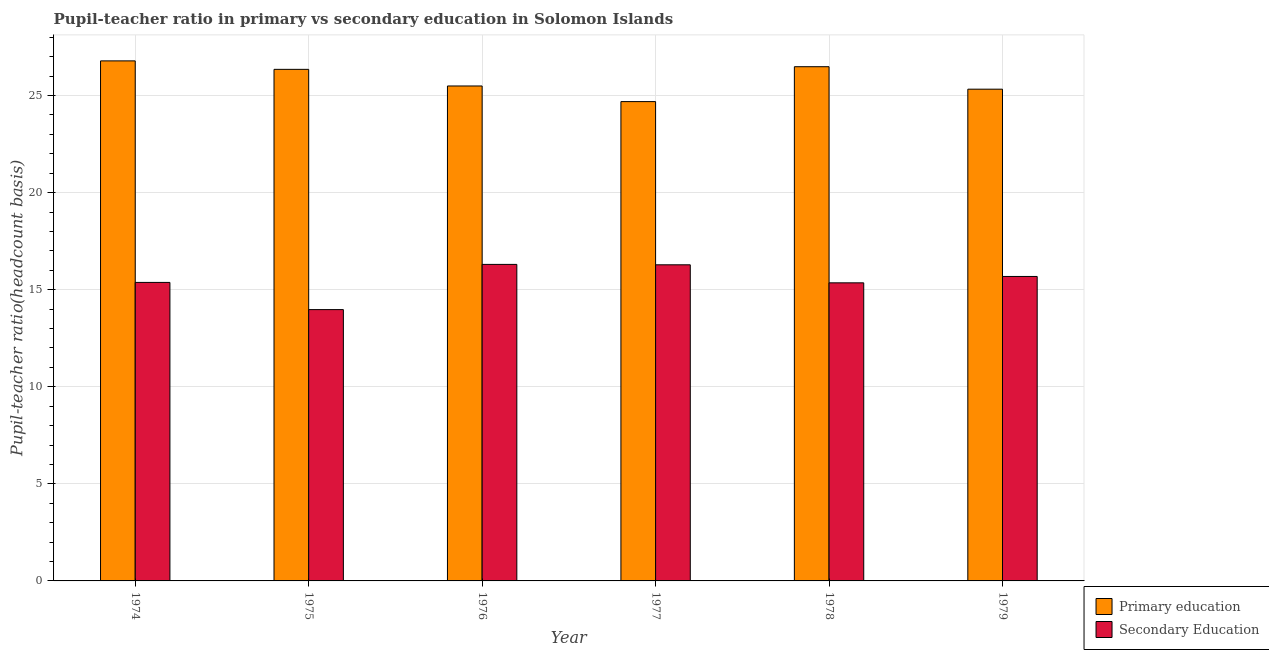Are the number of bars on each tick of the X-axis equal?
Keep it short and to the point. Yes. How many bars are there on the 2nd tick from the left?
Give a very brief answer. 2. How many bars are there on the 5th tick from the right?
Offer a terse response. 2. What is the label of the 5th group of bars from the left?
Your answer should be compact. 1978. What is the pupil-teacher ratio in primary education in 1979?
Offer a very short reply. 25.33. Across all years, what is the maximum pupil-teacher ratio in primary education?
Offer a terse response. 26.78. Across all years, what is the minimum pupil teacher ratio on secondary education?
Your answer should be compact. 13.97. In which year was the pupil teacher ratio on secondary education maximum?
Give a very brief answer. 1976. What is the total pupil-teacher ratio in primary education in the graph?
Offer a terse response. 155.12. What is the difference between the pupil-teacher ratio in primary education in 1977 and that in 1979?
Provide a succinct answer. -0.64. What is the difference between the pupil-teacher ratio in primary education in 1978 and the pupil teacher ratio on secondary education in 1977?
Make the answer very short. 1.8. What is the average pupil teacher ratio on secondary education per year?
Your answer should be very brief. 15.49. In the year 1976, what is the difference between the pupil teacher ratio on secondary education and pupil-teacher ratio in primary education?
Give a very brief answer. 0. In how many years, is the pupil-teacher ratio in primary education greater than 20?
Offer a terse response. 6. What is the ratio of the pupil-teacher ratio in primary education in 1976 to that in 1979?
Keep it short and to the point. 1.01. Is the pupil teacher ratio on secondary education in 1974 less than that in 1979?
Offer a very short reply. Yes. Is the difference between the pupil teacher ratio on secondary education in 1976 and 1979 greater than the difference between the pupil-teacher ratio in primary education in 1976 and 1979?
Ensure brevity in your answer.  No. What is the difference between the highest and the second highest pupil-teacher ratio in primary education?
Provide a succinct answer. 0.3. What is the difference between the highest and the lowest pupil-teacher ratio in primary education?
Your response must be concise. 2.1. In how many years, is the pupil-teacher ratio in primary education greater than the average pupil-teacher ratio in primary education taken over all years?
Ensure brevity in your answer.  3. Is the sum of the pupil-teacher ratio in primary education in 1976 and 1977 greater than the maximum pupil teacher ratio on secondary education across all years?
Provide a succinct answer. Yes. What does the 1st bar from the left in 1976 represents?
Make the answer very short. Primary education. How many bars are there?
Your answer should be compact. 12. What is the difference between two consecutive major ticks on the Y-axis?
Give a very brief answer. 5. Does the graph contain any zero values?
Offer a very short reply. No. Where does the legend appear in the graph?
Your answer should be compact. Bottom right. How many legend labels are there?
Provide a succinct answer. 2. What is the title of the graph?
Provide a succinct answer. Pupil-teacher ratio in primary vs secondary education in Solomon Islands. What is the label or title of the Y-axis?
Give a very brief answer. Pupil-teacher ratio(headcount basis). What is the Pupil-teacher ratio(headcount basis) in Primary education in 1974?
Offer a very short reply. 26.78. What is the Pupil-teacher ratio(headcount basis) in Secondary Education in 1974?
Your answer should be compact. 15.37. What is the Pupil-teacher ratio(headcount basis) of Primary education in 1975?
Your answer should be very brief. 26.35. What is the Pupil-teacher ratio(headcount basis) in Secondary Education in 1975?
Ensure brevity in your answer.  13.97. What is the Pupil-teacher ratio(headcount basis) of Primary education in 1976?
Make the answer very short. 25.49. What is the Pupil-teacher ratio(headcount basis) of Secondary Education in 1976?
Make the answer very short. 16.3. What is the Pupil-teacher ratio(headcount basis) in Primary education in 1977?
Provide a succinct answer. 24.69. What is the Pupil-teacher ratio(headcount basis) of Secondary Education in 1977?
Make the answer very short. 16.28. What is the Pupil-teacher ratio(headcount basis) of Primary education in 1978?
Your response must be concise. 26.48. What is the Pupil-teacher ratio(headcount basis) in Secondary Education in 1978?
Ensure brevity in your answer.  15.35. What is the Pupil-teacher ratio(headcount basis) of Primary education in 1979?
Provide a succinct answer. 25.33. What is the Pupil-teacher ratio(headcount basis) in Secondary Education in 1979?
Offer a very short reply. 15.68. Across all years, what is the maximum Pupil-teacher ratio(headcount basis) in Primary education?
Offer a very short reply. 26.78. Across all years, what is the maximum Pupil-teacher ratio(headcount basis) in Secondary Education?
Offer a terse response. 16.3. Across all years, what is the minimum Pupil-teacher ratio(headcount basis) of Primary education?
Make the answer very short. 24.69. Across all years, what is the minimum Pupil-teacher ratio(headcount basis) of Secondary Education?
Make the answer very short. 13.97. What is the total Pupil-teacher ratio(headcount basis) of Primary education in the graph?
Offer a terse response. 155.12. What is the total Pupil-teacher ratio(headcount basis) of Secondary Education in the graph?
Offer a very short reply. 92.97. What is the difference between the Pupil-teacher ratio(headcount basis) of Primary education in 1974 and that in 1975?
Provide a short and direct response. 0.44. What is the difference between the Pupil-teacher ratio(headcount basis) in Secondary Education in 1974 and that in 1975?
Keep it short and to the point. 1.4. What is the difference between the Pupil-teacher ratio(headcount basis) in Primary education in 1974 and that in 1976?
Make the answer very short. 1.29. What is the difference between the Pupil-teacher ratio(headcount basis) in Secondary Education in 1974 and that in 1976?
Provide a succinct answer. -0.93. What is the difference between the Pupil-teacher ratio(headcount basis) of Primary education in 1974 and that in 1977?
Give a very brief answer. 2.1. What is the difference between the Pupil-teacher ratio(headcount basis) in Secondary Education in 1974 and that in 1977?
Offer a terse response. -0.91. What is the difference between the Pupil-teacher ratio(headcount basis) in Primary education in 1974 and that in 1978?
Ensure brevity in your answer.  0.3. What is the difference between the Pupil-teacher ratio(headcount basis) in Secondary Education in 1974 and that in 1978?
Make the answer very short. 0.02. What is the difference between the Pupil-teacher ratio(headcount basis) of Primary education in 1974 and that in 1979?
Your answer should be compact. 1.46. What is the difference between the Pupil-teacher ratio(headcount basis) in Secondary Education in 1974 and that in 1979?
Offer a very short reply. -0.31. What is the difference between the Pupil-teacher ratio(headcount basis) in Primary education in 1975 and that in 1976?
Offer a very short reply. 0.86. What is the difference between the Pupil-teacher ratio(headcount basis) of Secondary Education in 1975 and that in 1976?
Offer a terse response. -2.33. What is the difference between the Pupil-teacher ratio(headcount basis) in Primary education in 1975 and that in 1977?
Provide a succinct answer. 1.66. What is the difference between the Pupil-teacher ratio(headcount basis) in Secondary Education in 1975 and that in 1977?
Make the answer very short. -2.31. What is the difference between the Pupil-teacher ratio(headcount basis) in Primary education in 1975 and that in 1978?
Your answer should be very brief. -0.14. What is the difference between the Pupil-teacher ratio(headcount basis) in Secondary Education in 1975 and that in 1978?
Provide a short and direct response. -1.38. What is the difference between the Pupil-teacher ratio(headcount basis) in Primary education in 1975 and that in 1979?
Your answer should be compact. 1.02. What is the difference between the Pupil-teacher ratio(headcount basis) in Secondary Education in 1975 and that in 1979?
Ensure brevity in your answer.  -1.71. What is the difference between the Pupil-teacher ratio(headcount basis) of Primary education in 1976 and that in 1977?
Provide a succinct answer. 0.8. What is the difference between the Pupil-teacher ratio(headcount basis) in Secondary Education in 1976 and that in 1977?
Offer a terse response. 0.02. What is the difference between the Pupil-teacher ratio(headcount basis) of Primary education in 1976 and that in 1978?
Your answer should be very brief. -0.99. What is the difference between the Pupil-teacher ratio(headcount basis) in Secondary Education in 1976 and that in 1978?
Provide a short and direct response. 0.95. What is the difference between the Pupil-teacher ratio(headcount basis) of Primary education in 1976 and that in 1979?
Your answer should be very brief. 0.16. What is the difference between the Pupil-teacher ratio(headcount basis) in Secondary Education in 1976 and that in 1979?
Provide a short and direct response. 0.62. What is the difference between the Pupil-teacher ratio(headcount basis) in Primary education in 1977 and that in 1978?
Make the answer very short. -1.8. What is the difference between the Pupil-teacher ratio(headcount basis) of Secondary Education in 1977 and that in 1978?
Offer a very short reply. 0.93. What is the difference between the Pupil-teacher ratio(headcount basis) of Primary education in 1977 and that in 1979?
Provide a short and direct response. -0.64. What is the difference between the Pupil-teacher ratio(headcount basis) of Secondary Education in 1977 and that in 1979?
Your answer should be very brief. 0.6. What is the difference between the Pupil-teacher ratio(headcount basis) in Primary education in 1978 and that in 1979?
Offer a terse response. 1.16. What is the difference between the Pupil-teacher ratio(headcount basis) in Secondary Education in 1978 and that in 1979?
Offer a very short reply. -0.33. What is the difference between the Pupil-teacher ratio(headcount basis) in Primary education in 1974 and the Pupil-teacher ratio(headcount basis) in Secondary Education in 1975?
Your answer should be compact. 12.81. What is the difference between the Pupil-teacher ratio(headcount basis) of Primary education in 1974 and the Pupil-teacher ratio(headcount basis) of Secondary Education in 1976?
Offer a terse response. 10.48. What is the difference between the Pupil-teacher ratio(headcount basis) of Primary education in 1974 and the Pupil-teacher ratio(headcount basis) of Secondary Education in 1977?
Give a very brief answer. 10.5. What is the difference between the Pupil-teacher ratio(headcount basis) in Primary education in 1974 and the Pupil-teacher ratio(headcount basis) in Secondary Education in 1978?
Your response must be concise. 11.43. What is the difference between the Pupil-teacher ratio(headcount basis) of Primary education in 1974 and the Pupil-teacher ratio(headcount basis) of Secondary Education in 1979?
Your response must be concise. 11.1. What is the difference between the Pupil-teacher ratio(headcount basis) in Primary education in 1975 and the Pupil-teacher ratio(headcount basis) in Secondary Education in 1976?
Provide a short and direct response. 10.05. What is the difference between the Pupil-teacher ratio(headcount basis) of Primary education in 1975 and the Pupil-teacher ratio(headcount basis) of Secondary Education in 1977?
Your answer should be very brief. 10.07. What is the difference between the Pupil-teacher ratio(headcount basis) in Primary education in 1975 and the Pupil-teacher ratio(headcount basis) in Secondary Education in 1978?
Offer a very short reply. 11. What is the difference between the Pupil-teacher ratio(headcount basis) in Primary education in 1975 and the Pupil-teacher ratio(headcount basis) in Secondary Education in 1979?
Make the answer very short. 10.67. What is the difference between the Pupil-teacher ratio(headcount basis) of Primary education in 1976 and the Pupil-teacher ratio(headcount basis) of Secondary Education in 1977?
Your answer should be very brief. 9.21. What is the difference between the Pupil-teacher ratio(headcount basis) of Primary education in 1976 and the Pupil-teacher ratio(headcount basis) of Secondary Education in 1978?
Your answer should be very brief. 10.14. What is the difference between the Pupil-teacher ratio(headcount basis) in Primary education in 1976 and the Pupil-teacher ratio(headcount basis) in Secondary Education in 1979?
Provide a short and direct response. 9.81. What is the difference between the Pupil-teacher ratio(headcount basis) of Primary education in 1977 and the Pupil-teacher ratio(headcount basis) of Secondary Education in 1978?
Keep it short and to the point. 9.33. What is the difference between the Pupil-teacher ratio(headcount basis) in Primary education in 1977 and the Pupil-teacher ratio(headcount basis) in Secondary Education in 1979?
Give a very brief answer. 9.01. What is the difference between the Pupil-teacher ratio(headcount basis) in Primary education in 1978 and the Pupil-teacher ratio(headcount basis) in Secondary Education in 1979?
Provide a succinct answer. 10.8. What is the average Pupil-teacher ratio(headcount basis) in Primary education per year?
Offer a terse response. 25.85. What is the average Pupil-teacher ratio(headcount basis) of Secondary Education per year?
Keep it short and to the point. 15.49. In the year 1974, what is the difference between the Pupil-teacher ratio(headcount basis) in Primary education and Pupil-teacher ratio(headcount basis) in Secondary Education?
Your answer should be very brief. 11.41. In the year 1975, what is the difference between the Pupil-teacher ratio(headcount basis) of Primary education and Pupil-teacher ratio(headcount basis) of Secondary Education?
Your answer should be compact. 12.37. In the year 1976, what is the difference between the Pupil-teacher ratio(headcount basis) of Primary education and Pupil-teacher ratio(headcount basis) of Secondary Education?
Offer a very short reply. 9.19. In the year 1977, what is the difference between the Pupil-teacher ratio(headcount basis) of Primary education and Pupil-teacher ratio(headcount basis) of Secondary Education?
Make the answer very short. 8.4. In the year 1978, what is the difference between the Pupil-teacher ratio(headcount basis) of Primary education and Pupil-teacher ratio(headcount basis) of Secondary Education?
Your response must be concise. 11.13. In the year 1979, what is the difference between the Pupil-teacher ratio(headcount basis) of Primary education and Pupil-teacher ratio(headcount basis) of Secondary Education?
Keep it short and to the point. 9.65. What is the ratio of the Pupil-teacher ratio(headcount basis) in Primary education in 1974 to that in 1975?
Give a very brief answer. 1.02. What is the ratio of the Pupil-teacher ratio(headcount basis) in Secondary Education in 1974 to that in 1975?
Offer a terse response. 1.1. What is the ratio of the Pupil-teacher ratio(headcount basis) in Primary education in 1974 to that in 1976?
Your answer should be very brief. 1.05. What is the ratio of the Pupil-teacher ratio(headcount basis) of Secondary Education in 1974 to that in 1976?
Provide a short and direct response. 0.94. What is the ratio of the Pupil-teacher ratio(headcount basis) in Primary education in 1974 to that in 1977?
Your response must be concise. 1.08. What is the ratio of the Pupil-teacher ratio(headcount basis) of Secondary Education in 1974 to that in 1977?
Provide a succinct answer. 0.94. What is the ratio of the Pupil-teacher ratio(headcount basis) in Primary education in 1974 to that in 1978?
Provide a succinct answer. 1.01. What is the ratio of the Pupil-teacher ratio(headcount basis) of Secondary Education in 1974 to that in 1978?
Make the answer very short. 1. What is the ratio of the Pupil-teacher ratio(headcount basis) of Primary education in 1974 to that in 1979?
Your answer should be very brief. 1.06. What is the ratio of the Pupil-teacher ratio(headcount basis) of Secondary Education in 1974 to that in 1979?
Your answer should be very brief. 0.98. What is the ratio of the Pupil-teacher ratio(headcount basis) of Primary education in 1975 to that in 1976?
Offer a very short reply. 1.03. What is the ratio of the Pupil-teacher ratio(headcount basis) of Secondary Education in 1975 to that in 1976?
Your response must be concise. 0.86. What is the ratio of the Pupil-teacher ratio(headcount basis) in Primary education in 1975 to that in 1977?
Make the answer very short. 1.07. What is the ratio of the Pupil-teacher ratio(headcount basis) of Secondary Education in 1975 to that in 1977?
Give a very brief answer. 0.86. What is the ratio of the Pupil-teacher ratio(headcount basis) of Primary education in 1975 to that in 1978?
Your answer should be compact. 0.99. What is the ratio of the Pupil-teacher ratio(headcount basis) of Secondary Education in 1975 to that in 1978?
Ensure brevity in your answer.  0.91. What is the ratio of the Pupil-teacher ratio(headcount basis) in Primary education in 1975 to that in 1979?
Your answer should be very brief. 1.04. What is the ratio of the Pupil-teacher ratio(headcount basis) in Secondary Education in 1975 to that in 1979?
Your answer should be compact. 0.89. What is the ratio of the Pupil-teacher ratio(headcount basis) of Primary education in 1976 to that in 1977?
Your answer should be compact. 1.03. What is the ratio of the Pupil-teacher ratio(headcount basis) in Secondary Education in 1976 to that in 1977?
Offer a very short reply. 1. What is the ratio of the Pupil-teacher ratio(headcount basis) of Primary education in 1976 to that in 1978?
Provide a short and direct response. 0.96. What is the ratio of the Pupil-teacher ratio(headcount basis) in Secondary Education in 1976 to that in 1978?
Your answer should be very brief. 1.06. What is the ratio of the Pupil-teacher ratio(headcount basis) in Primary education in 1976 to that in 1979?
Provide a short and direct response. 1.01. What is the ratio of the Pupil-teacher ratio(headcount basis) in Secondary Education in 1976 to that in 1979?
Give a very brief answer. 1.04. What is the ratio of the Pupil-teacher ratio(headcount basis) in Primary education in 1977 to that in 1978?
Offer a terse response. 0.93. What is the ratio of the Pupil-teacher ratio(headcount basis) of Secondary Education in 1977 to that in 1978?
Offer a terse response. 1.06. What is the ratio of the Pupil-teacher ratio(headcount basis) of Primary education in 1977 to that in 1979?
Your response must be concise. 0.97. What is the ratio of the Pupil-teacher ratio(headcount basis) of Secondary Education in 1977 to that in 1979?
Keep it short and to the point. 1.04. What is the ratio of the Pupil-teacher ratio(headcount basis) in Primary education in 1978 to that in 1979?
Your response must be concise. 1.05. What is the ratio of the Pupil-teacher ratio(headcount basis) of Secondary Education in 1978 to that in 1979?
Keep it short and to the point. 0.98. What is the difference between the highest and the second highest Pupil-teacher ratio(headcount basis) of Primary education?
Your response must be concise. 0.3. What is the difference between the highest and the second highest Pupil-teacher ratio(headcount basis) of Secondary Education?
Offer a terse response. 0.02. What is the difference between the highest and the lowest Pupil-teacher ratio(headcount basis) of Primary education?
Ensure brevity in your answer.  2.1. What is the difference between the highest and the lowest Pupil-teacher ratio(headcount basis) of Secondary Education?
Your answer should be compact. 2.33. 